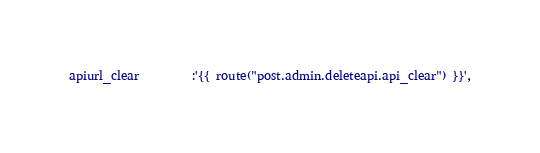Convert code to text. <code><loc_0><loc_0><loc_500><loc_500><_PHP_>apiurl_clear         :'{{ route("post.admin.deleteapi.api_clear") }}',</code> 